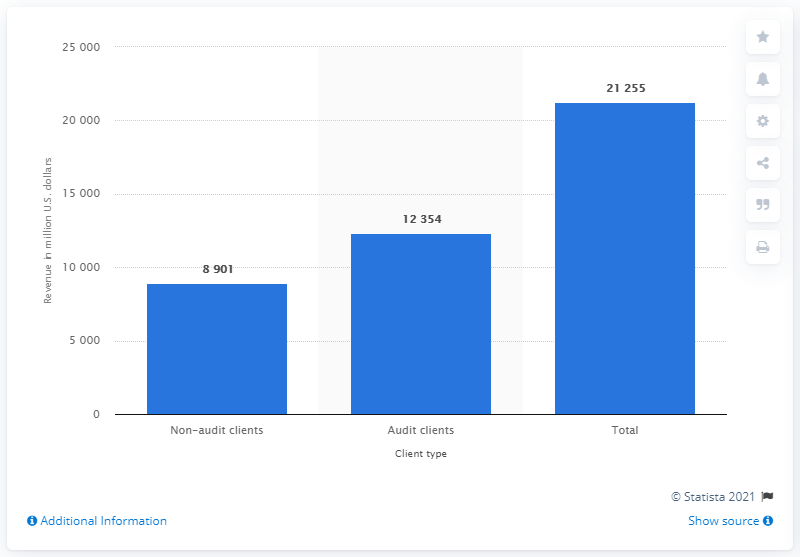Identify some key points in this picture. In 2010, the combined global revenues of Ernst & Young were $123,540. 